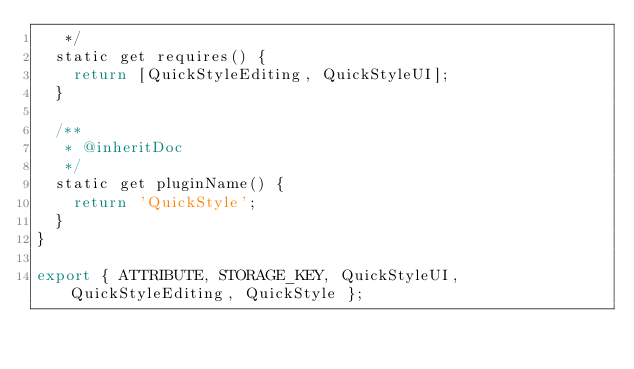<code> <loc_0><loc_0><loc_500><loc_500><_JavaScript_>	 */
	static get requires() {
		return [QuickStyleEditing, QuickStyleUI];
	}

	/**
	 * @inheritDoc
	 */
	static get pluginName() {
		return 'QuickStyle';
	}
}

export { ATTRIBUTE, STORAGE_KEY, QuickStyleUI, QuickStyleEditing, QuickStyle };
</code> 